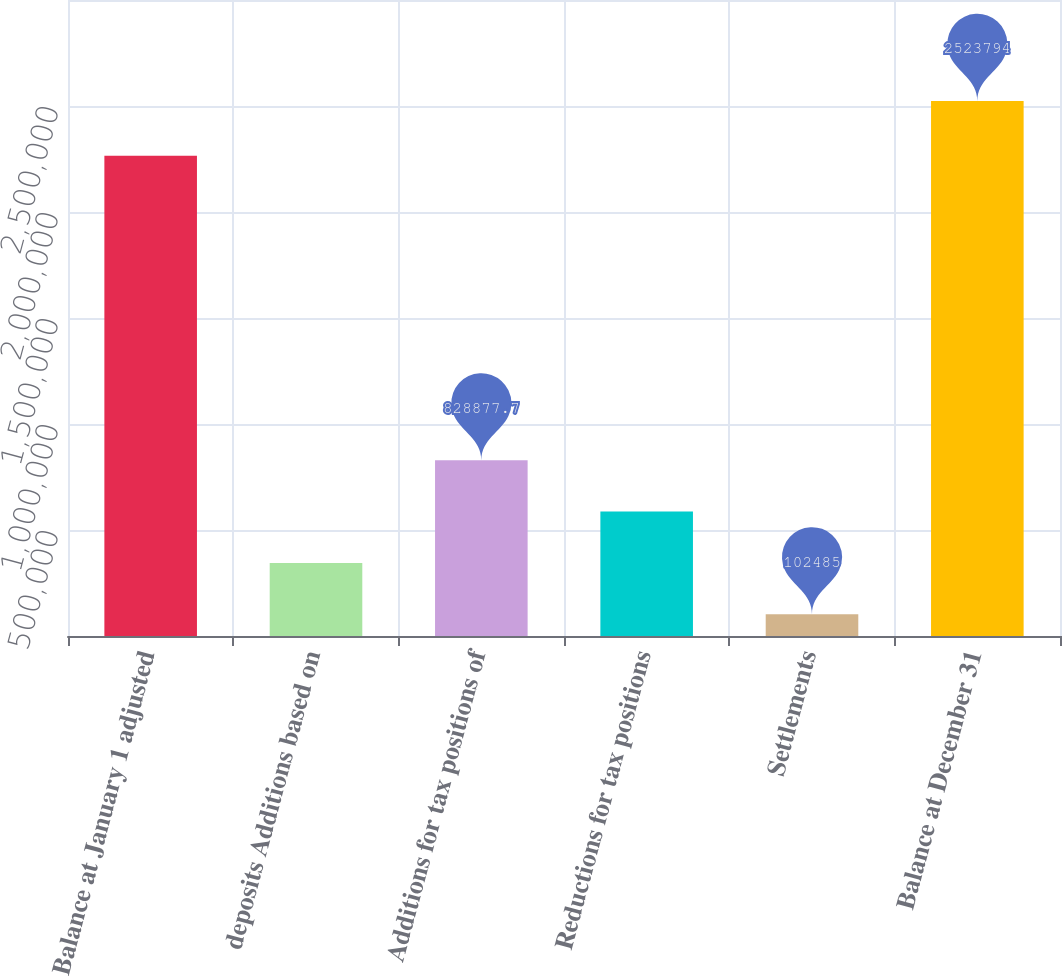Convert chart to OTSL. <chart><loc_0><loc_0><loc_500><loc_500><bar_chart><fcel>Balance at January 1 adjusted<fcel>deposits Additions based on<fcel>Additions for tax positions of<fcel>Reductions for tax positions<fcel>Settlements<fcel>Balance at December 31<nl><fcel>2.26526e+06<fcel>344616<fcel>828878<fcel>586747<fcel>102485<fcel>2.52379e+06<nl></chart> 